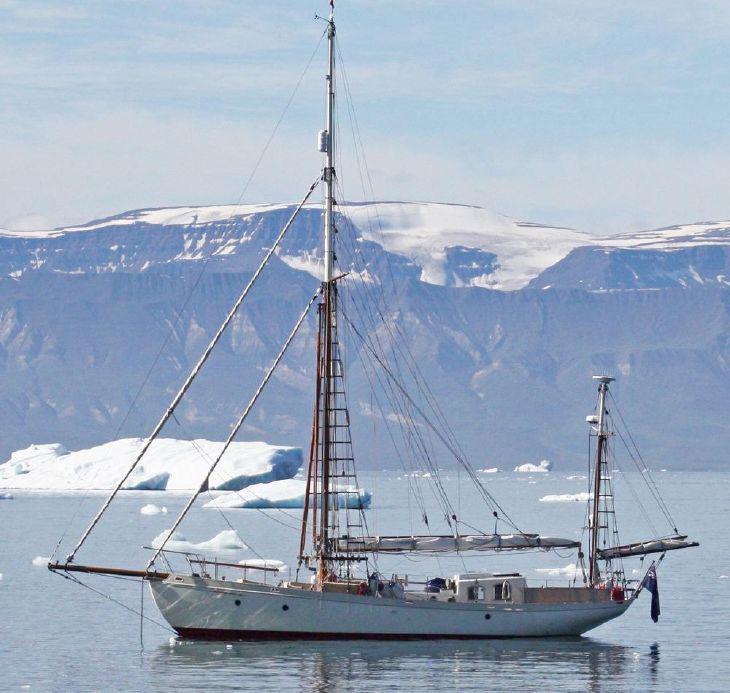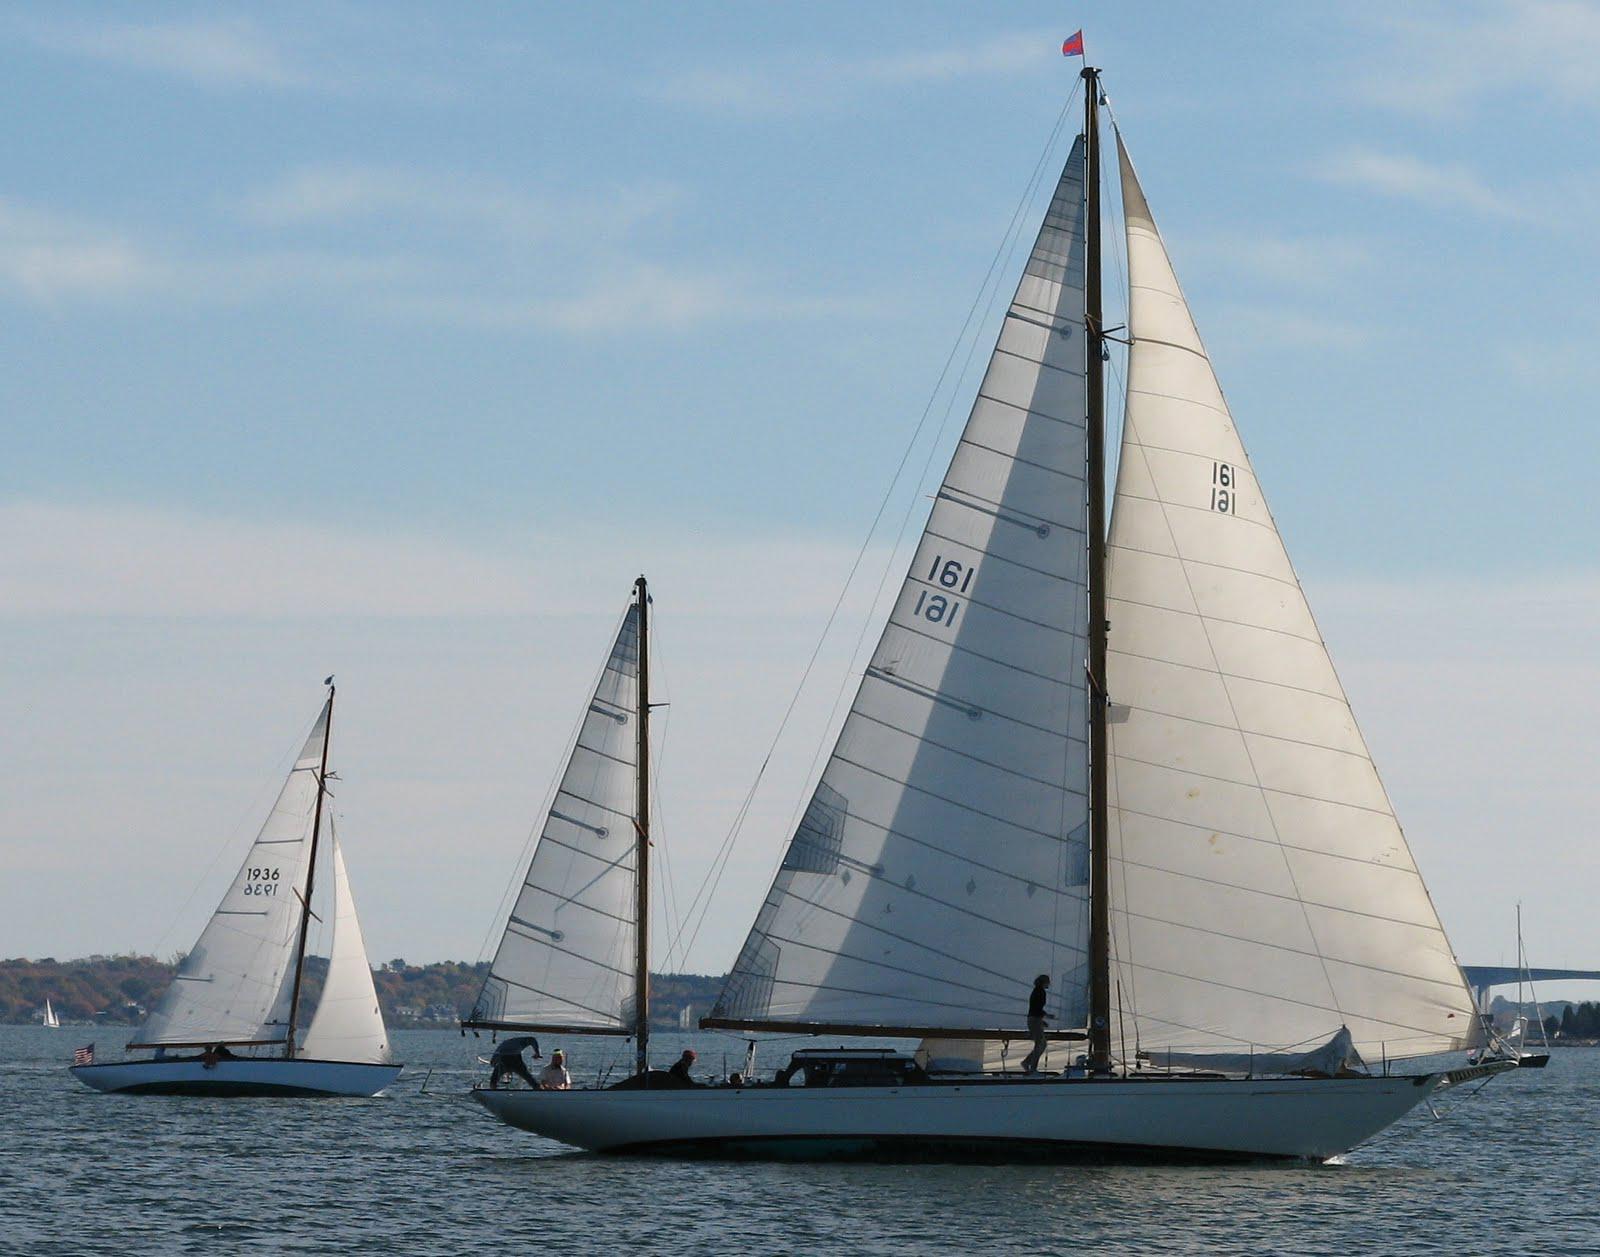The first image is the image on the left, the second image is the image on the right. For the images displayed, is the sentence "The sails on one of the ships is fully extended." factually correct? Answer yes or no. No. The first image is the image on the left, the second image is the image on the right. For the images displayed, is the sentence "A grassy hill is in the background of a sailboat." factually correct? Answer yes or no. No. 